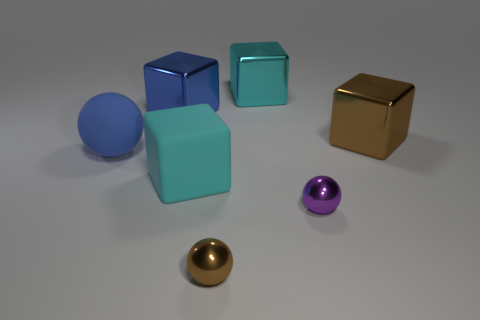Is the material of the large sphere the same as the big blue cube that is on the left side of the cyan metallic thing?
Ensure brevity in your answer.  No. Are there fewer cyan rubber cubes behind the big brown object than brown metal balls behind the blue block?
Keep it short and to the point. No. What is the color of the block in front of the big brown metal cube?
Offer a terse response. Cyan. What number of other objects are there of the same color as the big matte ball?
Give a very brief answer. 1. Is the size of the cyan block that is behind the blue metallic cube the same as the brown ball?
Offer a terse response. No. There is a purple sphere; how many large cubes are on the right side of it?
Your response must be concise. 1. Are there any gray matte balls of the same size as the matte block?
Offer a terse response. No. Is the big ball the same color as the large rubber cube?
Provide a succinct answer. No. What color is the big object that is in front of the ball that is behind the purple thing?
Offer a very short reply. Cyan. How many big things are left of the large matte cube and behind the blue rubber ball?
Your answer should be very brief. 1. 